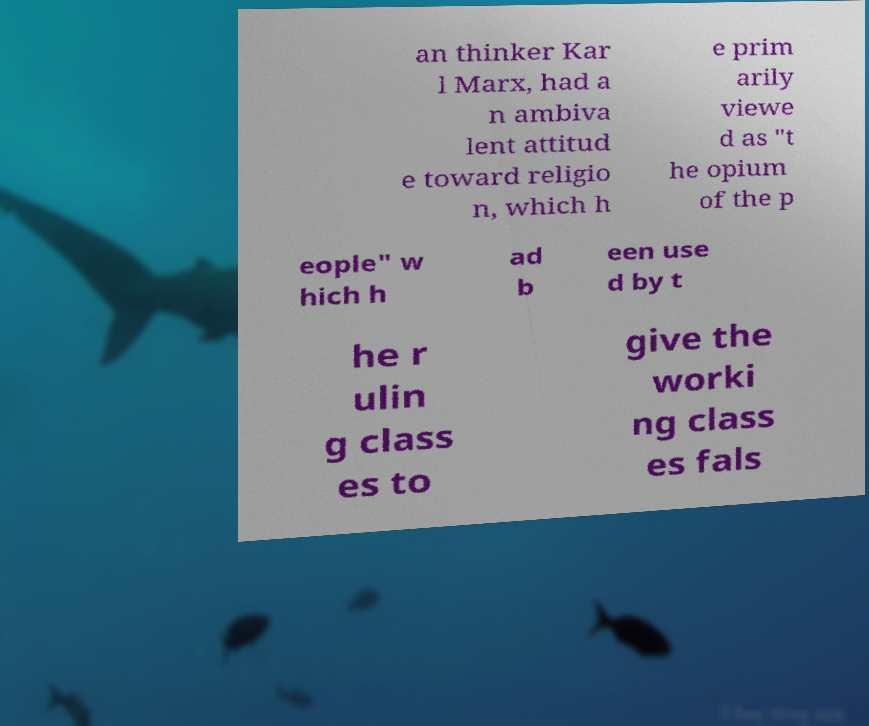Could you extract and type out the text from this image? an thinker Kar l Marx, had a n ambiva lent attitud e toward religio n, which h e prim arily viewe d as "t he opium of the p eople" w hich h ad b een use d by t he r ulin g class es to give the worki ng class es fals 